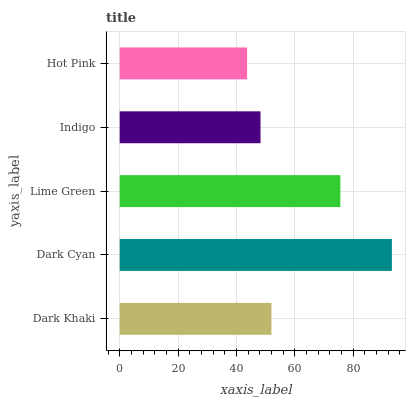Is Hot Pink the minimum?
Answer yes or no. Yes. Is Dark Cyan the maximum?
Answer yes or no. Yes. Is Lime Green the minimum?
Answer yes or no. No. Is Lime Green the maximum?
Answer yes or no. No. Is Dark Cyan greater than Lime Green?
Answer yes or no. Yes. Is Lime Green less than Dark Cyan?
Answer yes or no. Yes. Is Lime Green greater than Dark Cyan?
Answer yes or no. No. Is Dark Cyan less than Lime Green?
Answer yes or no. No. Is Dark Khaki the high median?
Answer yes or no. Yes. Is Dark Khaki the low median?
Answer yes or no. Yes. Is Dark Cyan the high median?
Answer yes or no. No. Is Hot Pink the low median?
Answer yes or no. No. 